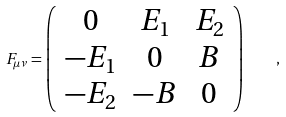Convert formula to latex. <formula><loc_0><loc_0><loc_500><loc_500>F _ { \mu \nu } = \left ( \begin{array} { c c c } 0 & E _ { 1 } & E _ { 2 } \\ - E _ { 1 } & 0 & B \\ - E _ { 2 } & - B & 0 \\ \end{array} \right ) \quad ,</formula> 